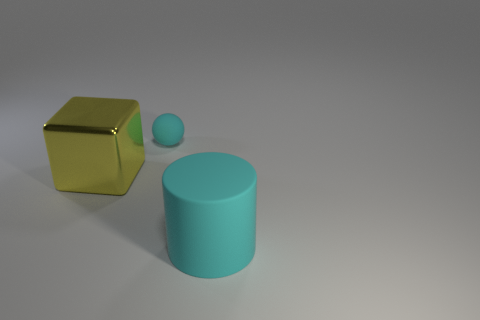Add 3 tiny gray balls. How many objects exist? 6 Subtract all cylinders. How many objects are left? 2 Subtract all gray spheres. Subtract all brown cylinders. How many spheres are left? 1 Subtract all large objects. Subtract all brown matte balls. How many objects are left? 1 Add 2 large cylinders. How many large cylinders are left? 3 Add 1 large shiny blocks. How many large shiny blocks exist? 2 Subtract 0 red cylinders. How many objects are left? 3 